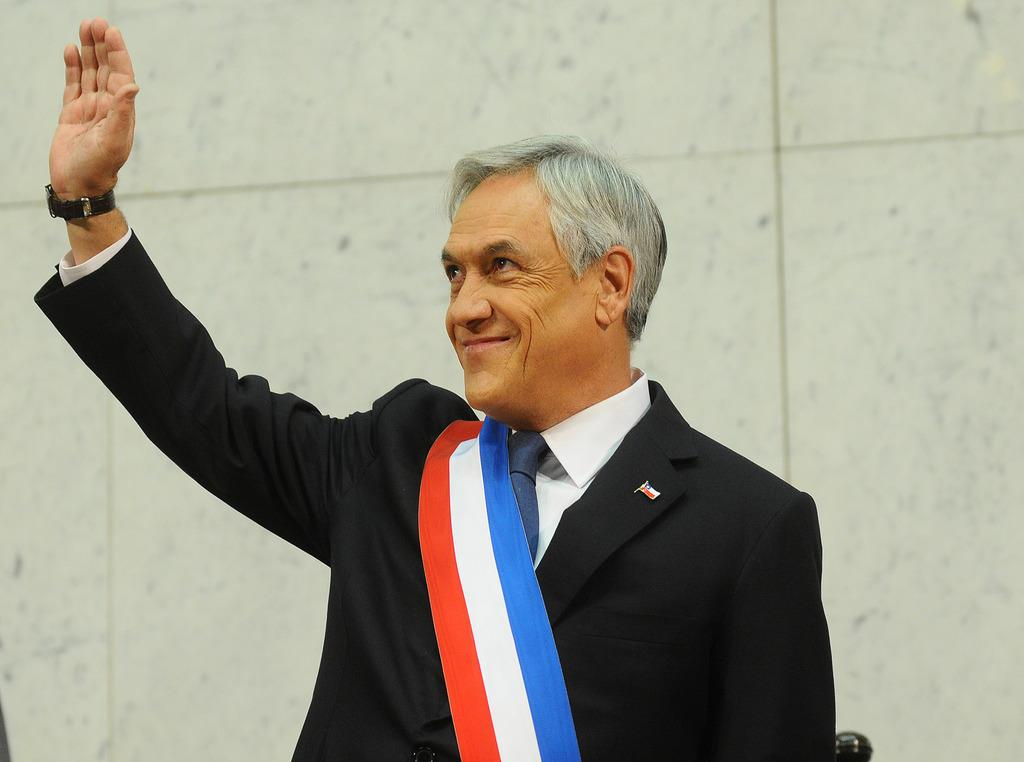Who is present in the image? There is a man in the image. What is the man's facial expression? The man is smiling. What is the man wearing? The man is wearing a black suit, a tie, a shirt, and a watch. What can be seen in the background of the image? There is a wall in the background of the image. How many metal legs does the man have in the image? The man does not have metal legs in the image; he has two human legs. 